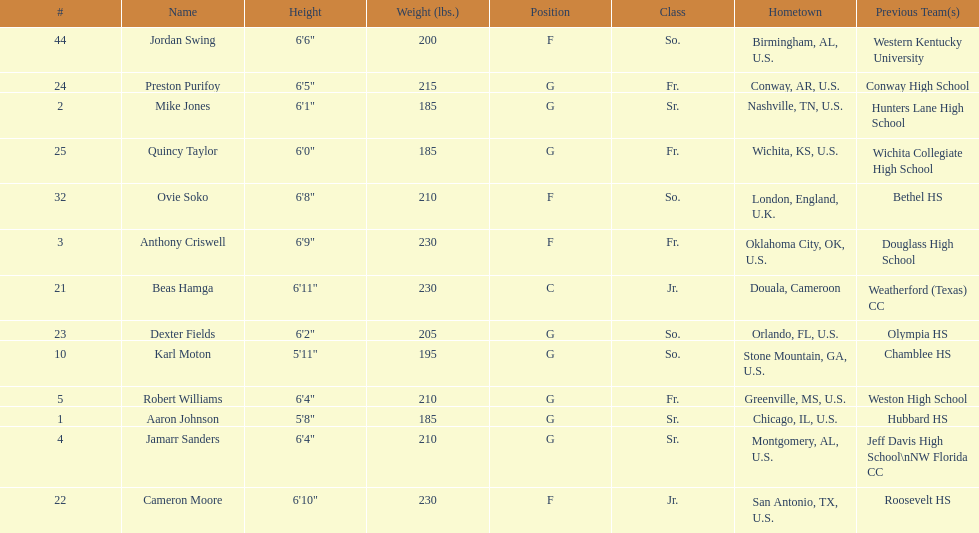How many players were on the 2010-11 uab blazers men's basketball team? 13. 